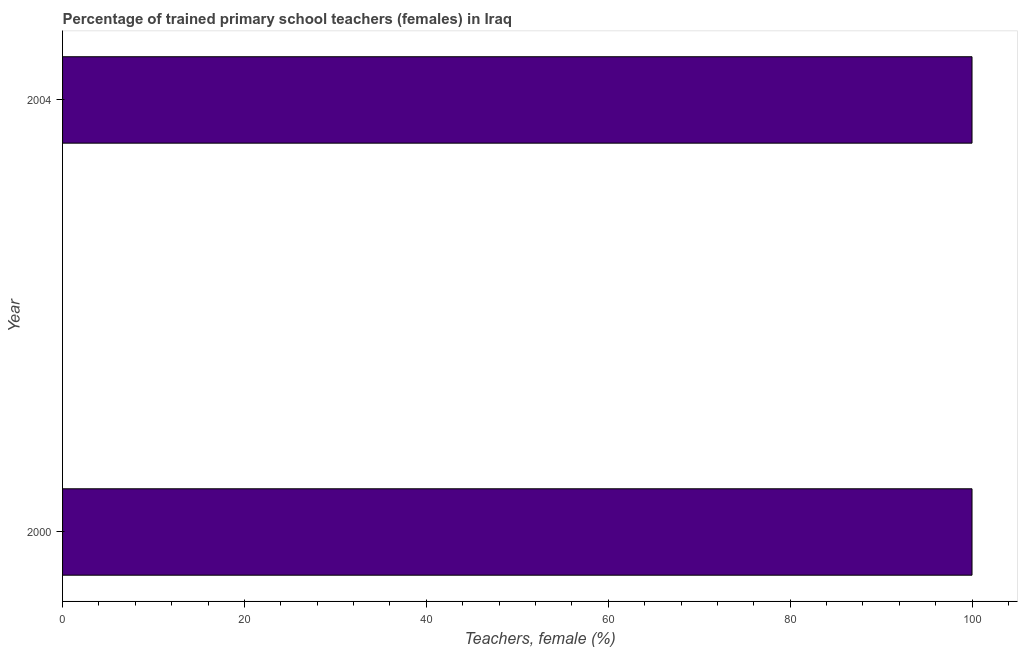Does the graph contain grids?
Keep it short and to the point. No. What is the title of the graph?
Ensure brevity in your answer.  Percentage of trained primary school teachers (females) in Iraq. What is the label or title of the X-axis?
Your answer should be very brief. Teachers, female (%). What is the percentage of trained female teachers in 2000?
Provide a short and direct response. 100. In which year was the percentage of trained female teachers minimum?
Your response must be concise. 2000. What is the difference between the percentage of trained female teachers in 2000 and 2004?
Offer a terse response. 0. What is the average percentage of trained female teachers per year?
Offer a terse response. 100. In how many years, is the percentage of trained female teachers greater than 20 %?
Your answer should be compact. 2. Is the percentage of trained female teachers in 2000 less than that in 2004?
Your answer should be compact. No. In how many years, is the percentage of trained female teachers greater than the average percentage of trained female teachers taken over all years?
Ensure brevity in your answer.  0. How many bars are there?
Your response must be concise. 2. Are the values on the major ticks of X-axis written in scientific E-notation?
Offer a very short reply. No. What is the Teachers, female (%) of 2000?
Give a very brief answer. 100. What is the ratio of the Teachers, female (%) in 2000 to that in 2004?
Your response must be concise. 1. 